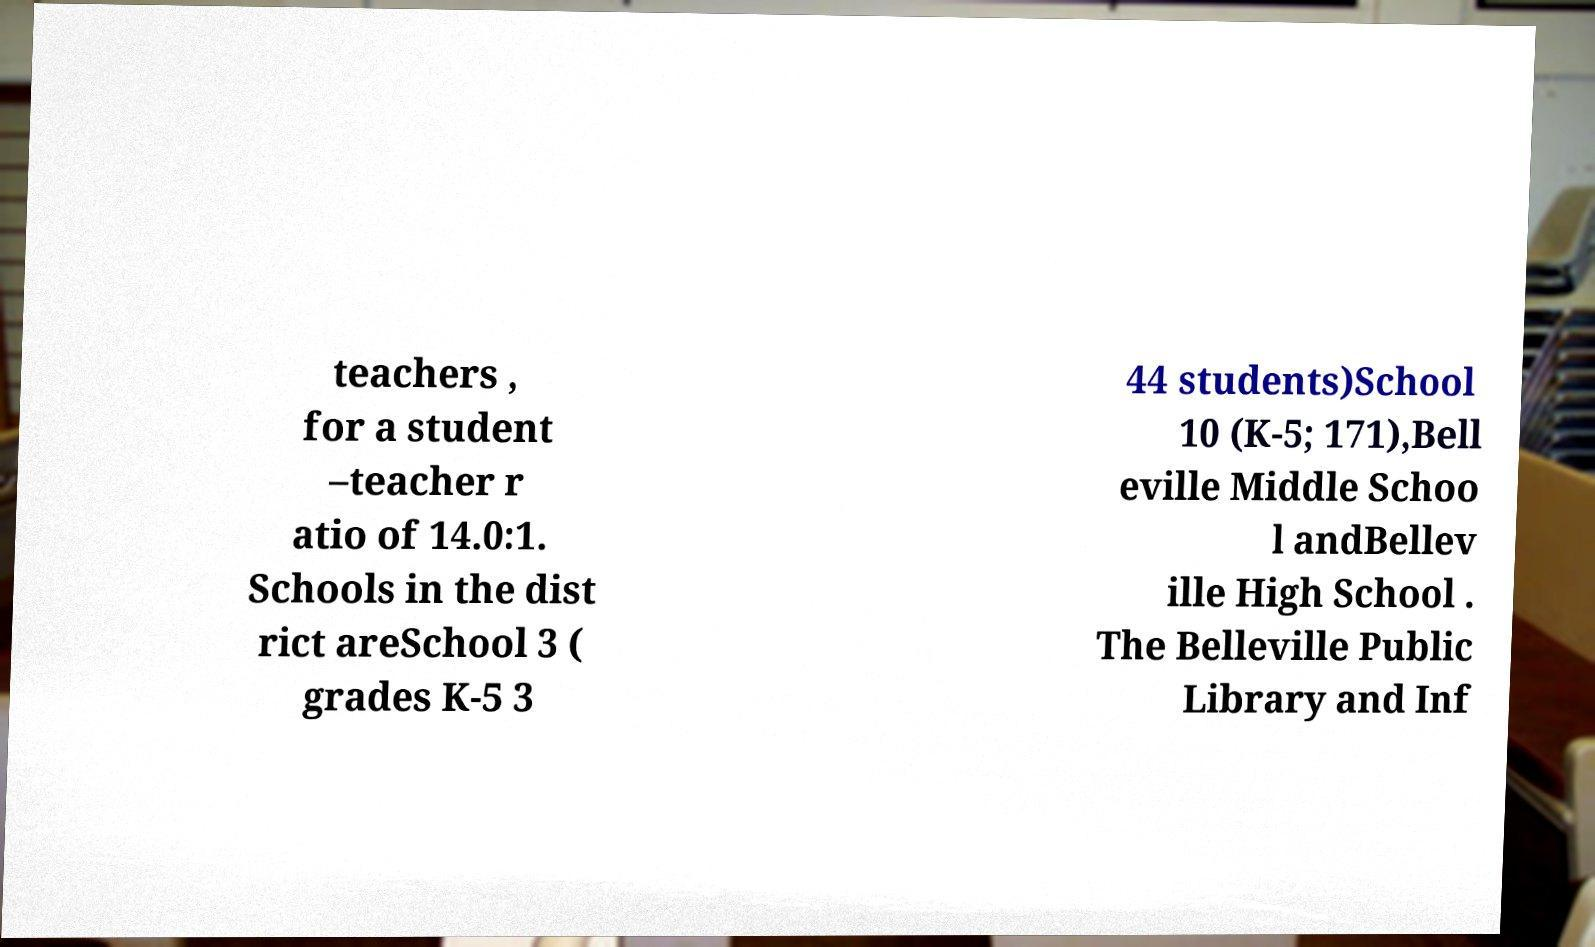Could you extract and type out the text from this image? teachers , for a student –teacher r atio of 14.0:1. Schools in the dist rict areSchool 3 ( grades K-5 3 44 students)School 10 (K-5; 171),Bell eville Middle Schoo l andBellev ille High School . The Belleville Public Library and Inf 